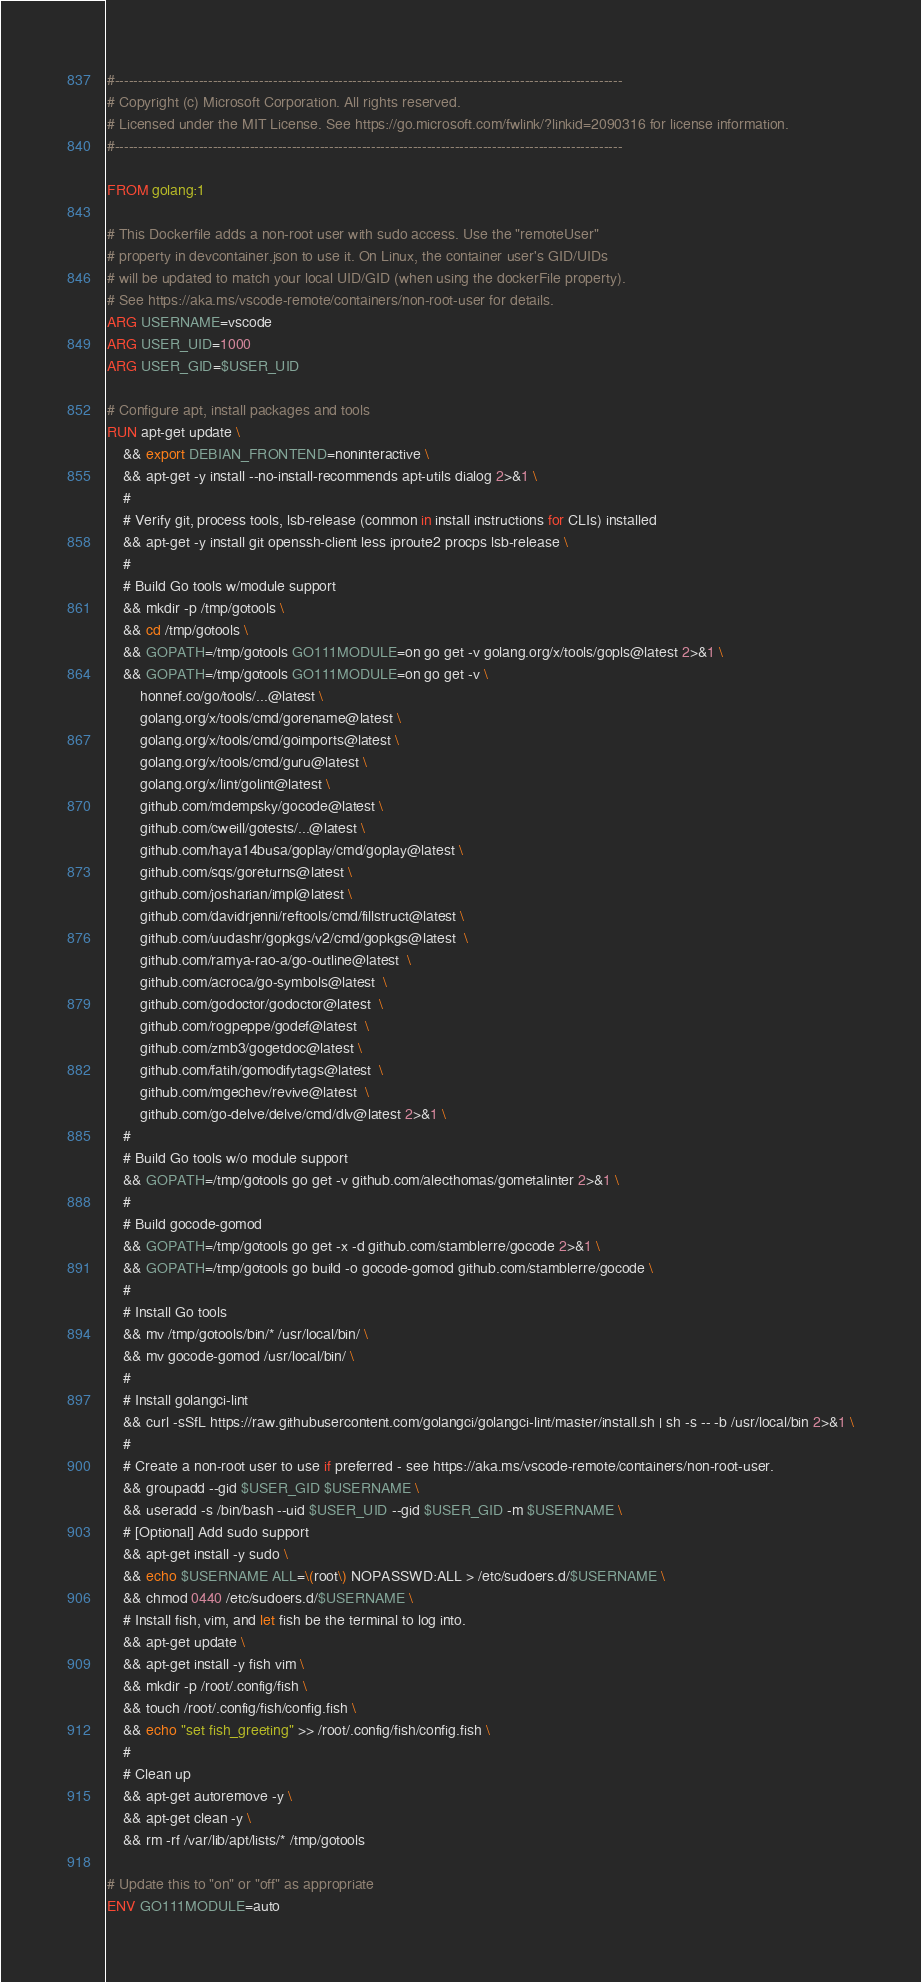<code> <loc_0><loc_0><loc_500><loc_500><_Dockerfile_>#-------------------------------------------------------------------------------------------------------------
# Copyright (c) Microsoft Corporation. All rights reserved.
# Licensed under the MIT License. See https://go.microsoft.com/fwlink/?linkid=2090316 for license information.
#-------------------------------------------------------------------------------------------------------------

FROM golang:1

# This Dockerfile adds a non-root user with sudo access. Use the "remoteUser"
# property in devcontainer.json to use it. On Linux, the container user's GID/UIDs
# will be updated to match your local UID/GID (when using the dockerFile property).
# See https://aka.ms/vscode-remote/containers/non-root-user for details.
ARG USERNAME=vscode
ARG USER_UID=1000
ARG USER_GID=$USER_UID

# Configure apt, install packages and tools
RUN apt-get update \
    && export DEBIAN_FRONTEND=noninteractive \
    && apt-get -y install --no-install-recommends apt-utils dialog 2>&1 \
    #
    # Verify git, process tools, lsb-release (common in install instructions for CLIs) installed
    && apt-get -y install git openssh-client less iproute2 procps lsb-release \
    #
    # Build Go tools w/module support
    && mkdir -p /tmp/gotools \
    && cd /tmp/gotools \
    && GOPATH=/tmp/gotools GO111MODULE=on go get -v golang.org/x/tools/gopls@latest 2>&1 \
    && GOPATH=/tmp/gotools GO111MODULE=on go get -v \
        honnef.co/go/tools/...@latest \
        golang.org/x/tools/cmd/gorename@latest \
        golang.org/x/tools/cmd/goimports@latest \
        golang.org/x/tools/cmd/guru@latest \
        golang.org/x/lint/golint@latest \
        github.com/mdempsky/gocode@latest \
        github.com/cweill/gotests/...@latest \
        github.com/haya14busa/goplay/cmd/goplay@latest \
        github.com/sqs/goreturns@latest \
        github.com/josharian/impl@latest \
        github.com/davidrjenni/reftools/cmd/fillstruct@latest \
        github.com/uudashr/gopkgs/v2/cmd/gopkgs@latest  \
        github.com/ramya-rao-a/go-outline@latest  \
        github.com/acroca/go-symbols@latest  \
        github.com/godoctor/godoctor@latest  \
        github.com/rogpeppe/godef@latest  \
        github.com/zmb3/gogetdoc@latest \
        github.com/fatih/gomodifytags@latest  \
        github.com/mgechev/revive@latest  \
        github.com/go-delve/delve/cmd/dlv@latest 2>&1 \
    #
    # Build Go tools w/o module support
    && GOPATH=/tmp/gotools go get -v github.com/alecthomas/gometalinter 2>&1 \
    #
    # Build gocode-gomod
    && GOPATH=/tmp/gotools go get -x -d github.com/stamblerre/gocode 2>&1 \
    && GOPATH=/tmp/gotools go build -o gocode-gomod github.com/stamblerre/gocode \
    #
    # Install Go tools
    && mv /tmp/gotools/bin/* /usr/local/bin/ \
    && mv gocode-gomod /usr/local/bin/ \
    #
    # Install golangci-lint
    && curl -sSfL https://raw.githubusercontent.com/golangci/golangci-lint/master/install.sh | sh -s -- -b /usr/local/bin 2>&1 \
    #
    # Create a non-root user to use if preferred - see https://aka.ms/vscode-remote/containers/non-root-user.
    && groupadd --gid $USER_GID $USERNAME \
    && useradd -s /bin/bash --uid $USER_UID --gid $USER_GID -m $USERNAME \
    # [Optional] Add sudo support
    && apt-get install -y sudo \
    && echo $USERNAME ALL=\(root\) NOPASSWD:ALL > /etc/sudoers.d/$USERNAME \
    && chmod 0440 /etc/sudoers.d/$USERNAME \
    # Install fish, vim, and let fish be the terminal to log into.
    && apt-get update \
    && apt-get install -y fish vim \
    && mkdir -p /root/.config/fish \
    && touch /root/.config/fish/config.fish \
    && echo "set fish_greeting" >> /root/.config/fish/config.fish \
    #
    # Clean up
    && apt-get autoremove -y \
    && apt-get clean -y \
    && rm -rf /var/lib/apt/lists/* /tmp/gotools

# Update this to "on" or "off" as appropriate
ENV GO111MODULE=auto

</code> 